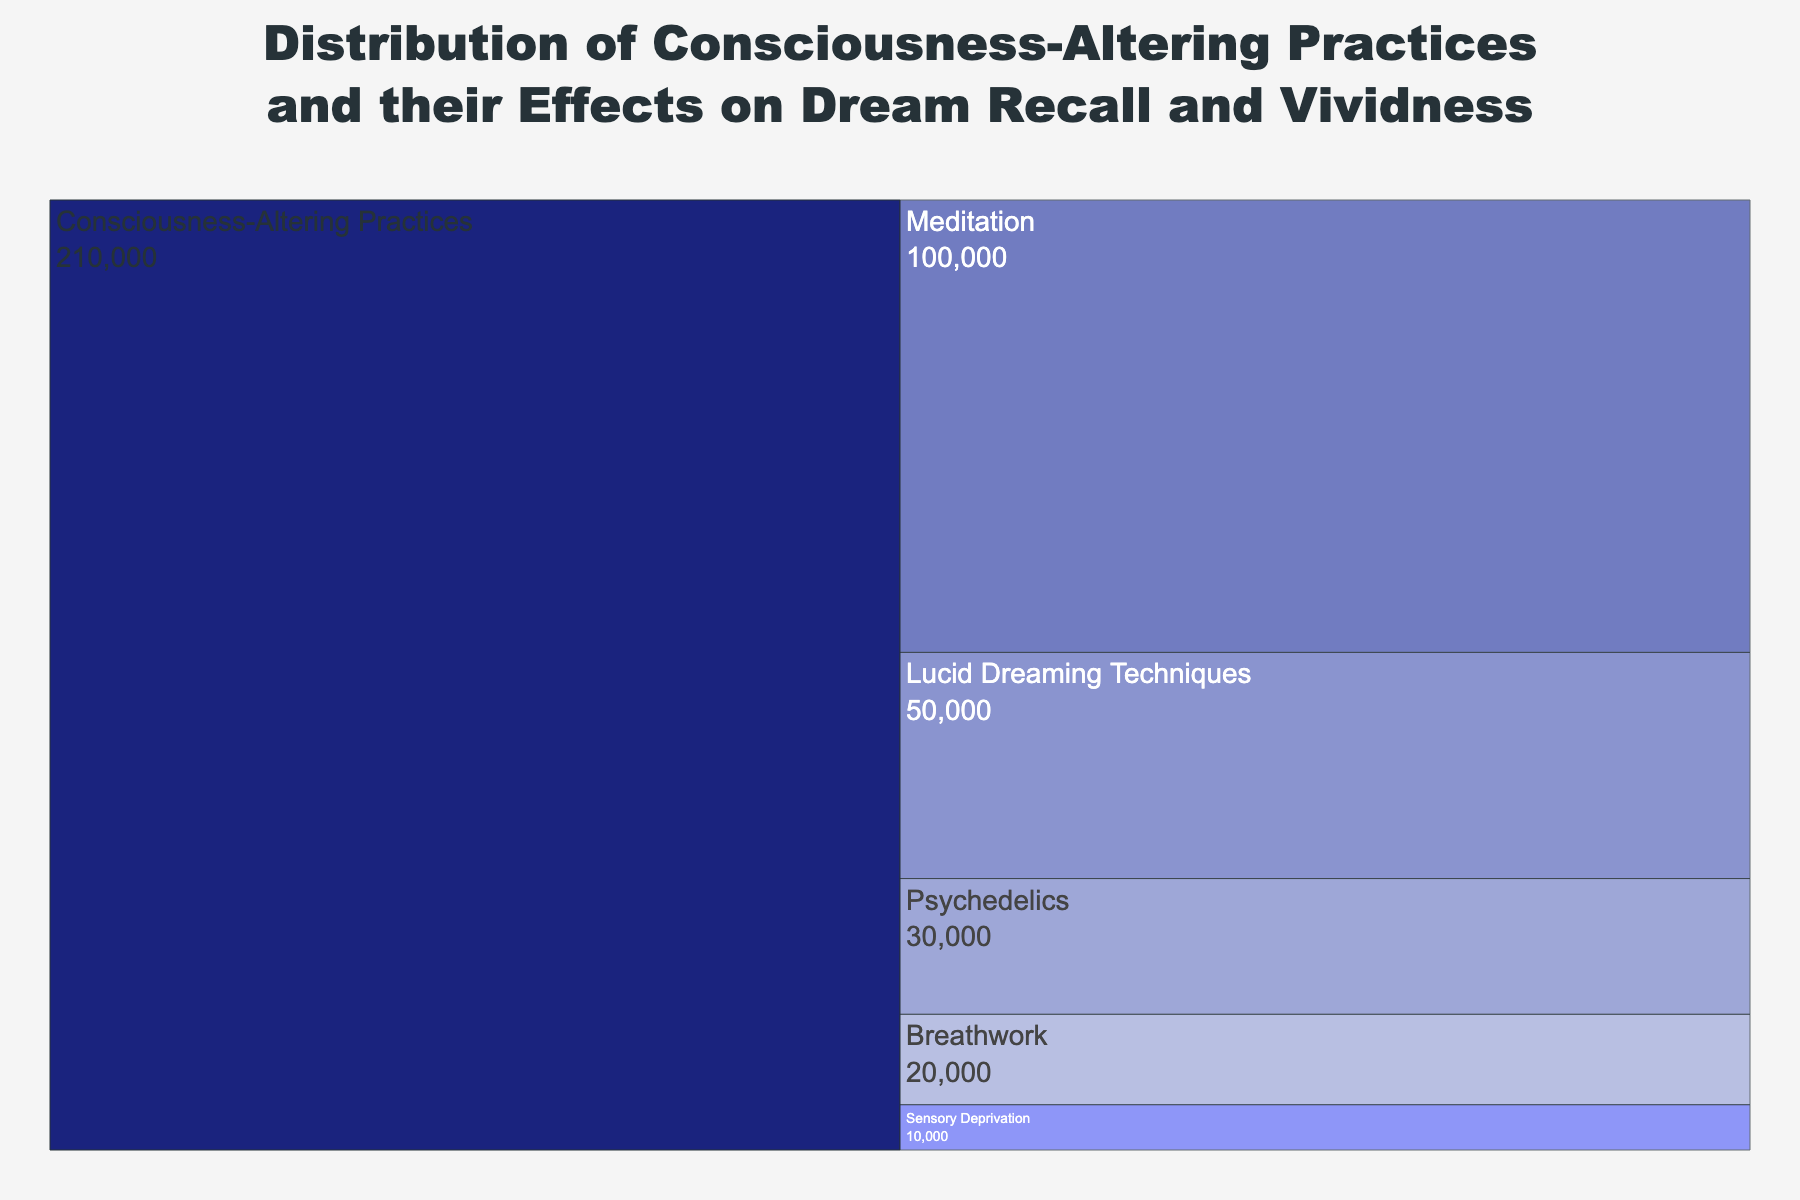What's the title of the figure? The title is found at the top of the chart and provides an overview of what the chart is about. Here, the title touches upon the distribution of practices and their effects.
Answer: Distribution of Consciousness-Altering Practices and their Effects on Dream Recall and Vividness Which practice has the most significant number of practitioners? Identify the practice with the largest value in relation to its branch to determine the one with the most practitioners.
Answer: Meditation How many practitioners use Breathwork? Look at the value next to the label "Breathwork" in the chart.
Answer: 20000 What is the median number of practitioners among all practices? First, list the number of practitioners for each practice in ascending order: 10000, 20000, 30000, 50000, 100000. The median is the middle value in this ordered list.
Answer: 30000 Which practice has the highest dream recall percentage? Check the custom data in the hover template for each practice and identify the one with the highest percentage under "Dream Recall."
Answer: Lucid Dreaming Techniques Compare the dream vividness percentages between Psychedelics and Sensory Deprivation. Which one is higher and by how much? Review the dream vividness percentages for both practices: Psychedelics (85%) and Sensory Deprivation (75%). Subtract the lower percentage from the higher one.
Answer: Psychedelics by 10% What is the overall sum of practitioners among all consciousness-altering practices? Add up the practitioners for all practices: 100000 (Meditation) + 50000 (Lucid Dreaming Techniques) + 30000 (Psychedelics) + 20000 (Breathwork) + 10000 (Sensory Deprivation).
Answer: 210000 What is the dream recall rate for the practice with the fewest practitioners? Identify the practice with the fewest practitioners and check its dream recall percentage. Sensory Deprivation has the fewest practitioners.
Answer: 65% Which practice shows the smallest difference between dream recall and dream vividness? Calculate the difference between dream recall and dream vividness for each practice and identify the smallest difference. Look at Meditation: 70% - 60% = 10%. Also, calculate for others if needed to confirm.
Answer: Meditation What portion of the total practitioners use techniques associated with Lucid Dreaming? Divide the number of practitioners of Lucid Dreaming Techniques by the total number of practitioners and multiply by 100 to get the percentage. (50000 / 210000) * 100 ≈ 23.8%.
Answer: Approximately 23.8% 